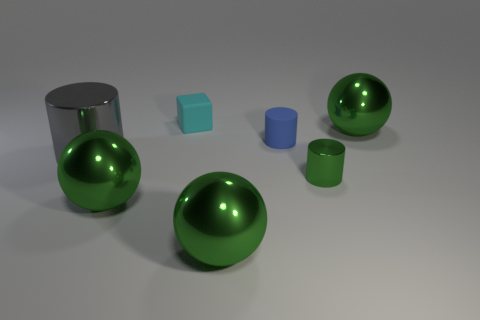Are there fewer tiny blocks than small objects?
Your answer should be very brief. Yes. Are there any brown metal cylinders of the same size as the blue cylinder?
Offer a terse response. No. There is a large gray object; is its shape the same as the matte thing in front of the small cyan rubber block?
Your answer should be very brief. Yes. How many blocks are either big purple objects or tiny things?
Ensure brevity in your answer.  1. The cube is what color?
Make the answer very short. Cyan. Are there more tiny blue matte things than tiny brown cubes?
Make the answer very short. Yes. What number of things are small cyan rubber objects that are left of the rubber cylinder or blue matte things?
Make the answer very short. 2. Does the large cylinder have the same material as the block?
Make the answer very short. No. What is the size of the blue object that is the same shape as the small green metallic thing?
Offer a very short reply. Small. Is the shape of the green metal thing that is behind the tiny green shiny cylinder the same as the matte object in front of the small rubber cube?
Your response must be concise. No. 